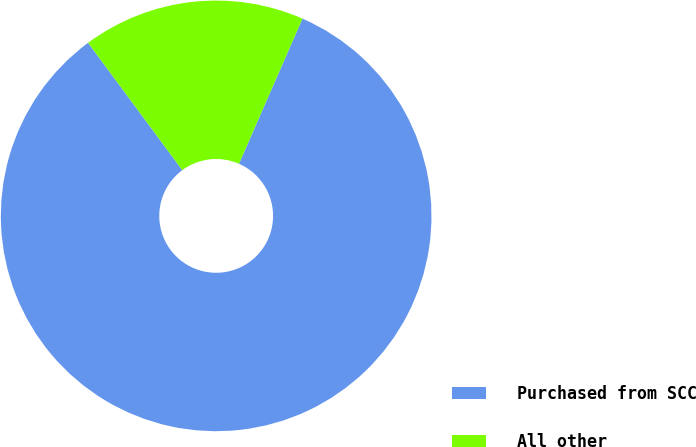Convert chart. <chart><loc_0><loc_0><loc_500><loc_500><pie_chart><fcel>Purchased from SCC<fcel>All other<nl><fcel>83.3%<fcel>16.7%<nl></chart> 